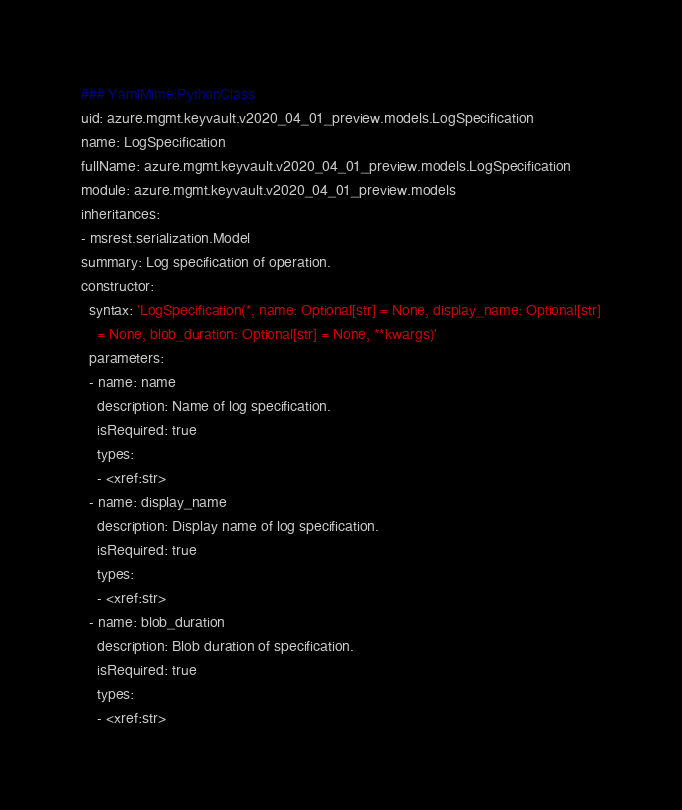Convert code to text. <code><loc_0><loc_0><loc_500><loc_500><_YAML_>### YamlMime:PythonClass
uid: azure.mgmt.keyvault.v2020_04_01_preview.models.LogSpecification
name: LogSpecification
fullName: azure.mgmt.keyvault.v2020_04_01_preview.models.LogSpecification
module: azure.mgmt.keyvault.v2020_04_01_preview.models
inheritances:
- msrest.serialization.Model
summary: Log specification of operation.
constructor:
  syntax: 'LogSpecification(*, name: Optional[str] = None, display_name: Optional[str]
    = None, blob_duration: Optional[str] = None, **kwargs)'
  parameters:
  - name: name
    description: Name of log specification.
    isRequired: true
    types:
    - <xref:str>
  - name: display_name
    description: Display name of log specification.
    isRequired: true
    types:
    - <xref:str>
  - name: blob_duration
    description: Blob duration of specification.
    isRequired: true
    types:
    - <xref:str>
</code> 